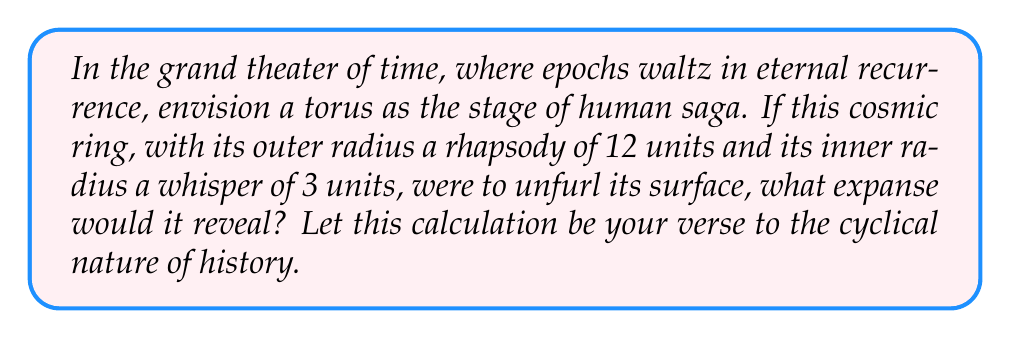Show me your answer to this math problem. To calculate the surface area of a torus, we shall follow these poetic steps:

1) The surface area of a torus is given by the formula:
   $$A = 4\pi^2Rr$$
   where $R$ is the distance from the center of the tube to the center of the torus (outer radius), and $r$ is the radius of the tube (inner radius).

2) From the question, we discern:
   $R = 12$ units (outer radius)
   $r = 3$ units (inner radius)

3) Let us now weave these values into our formula:
   $$A = 4\pi^2 \cdot 12 \cdot 3$$

4) Simplify the constants:
   $$A = 144\pi^2$$

5) To give a numerical approximation, we calculate:
   $$A \approx 1425.39 \text{ square units}$$

Thus, like the recurring themes in Russian literature, our torus unfurls its surface, revealing the vast expanse of historical cycles.
Answer: $144\pi^2 \text{ square units}$ (or approximately 1425.39 square units) 